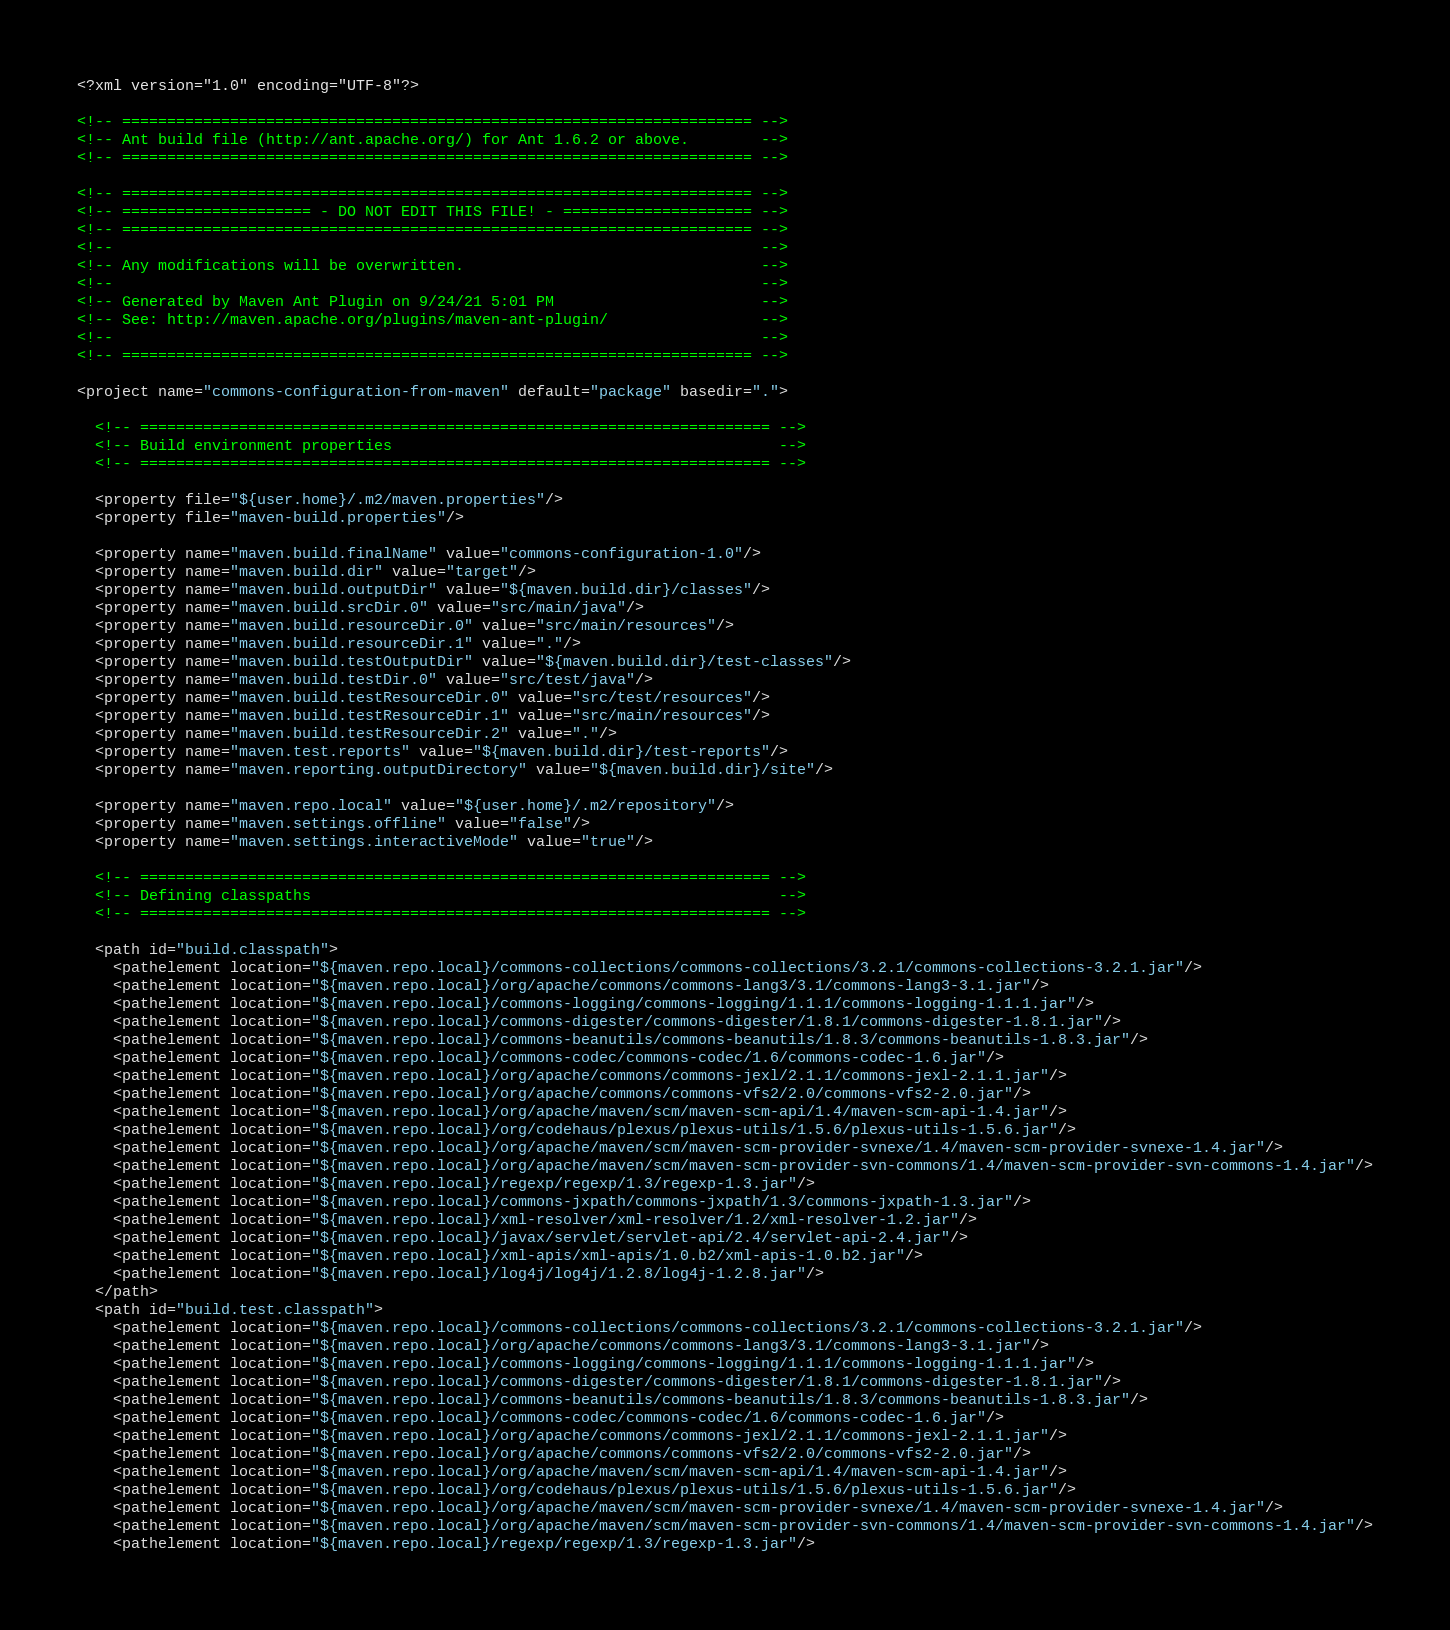Convert code to text. <code><loc_0><loc_0><loc_500><loc_500><_XML_><?xml version="1.0" encoding="UTF-8"?>

<!-- ====================================================================== -->
<!-- Ant build file (http://ant.apache.org/) for Ant 1.6.2 or above.        -->
<!-- ====================================================================== -->

<!-- ====================================================================== -->
<!-- ===================== - DO NOT EDIT THIS FILE! - ===================== -->
<!-- ====================================================================== -->
<!--                                                                        -->
<!-- Any modifications will be overwritten.                                 -->
<!--                                                                        -->
<!-- Generated by Maven Ant Plugin on 9/24/21 5:01 PM                       -->
<!-- See: http://maven.apache.org/plugins/maven-ant-plugin/                 -->
<!--                                                                        -->
<!-- ====================================================================== -->

<project name="commons-configuration-from-maven" default="package" basedir=".">

  <!-- ====================================================================== -->
  <!-- Build environment properties                                           -->
  <!-- ====================================================================== -->

  <property file="${user.home}/.m2/maven.properties"/>
  <property file="maven-build.properties"/>

  <property name="maven.build.finalName" value="commons-configuration-1.0"/>
  <property name="maven.build.dir" value="target"/>
  <property name="maven.build.outputDir" value="${maven.build.dir}/classes"/>
  <property name="maven.build.srcDir.0" value="src/main/java"/>
  <property name="maven.build.resourceDir.0" value="src/main/resources"/>
  <property name="maven.build.resourceDir.1" value="."/>
  <property name="maven.build.testOutputDir" value="${maven.build.dir}/test-classes"/>
  <property name="maven.build.testDir.0" value="src/test/java"/>
  <property name="maven.build.testResourceDir.0" value="src/test/resources"/>
  <property name="maven.build.testResourceDir.1" value="src/main/resources"/>
  <property name="maven.build.testResourceDir.2" value="."/>
  <property name="maven.test.reports" value="${maven.build.dir}/test-reports"/>
  <property name="maven.reporting.outputDirectory" value="${maven.build.dir}/site"/>

  <property name="maven.repo.local" value="${user.home}/.m2/repository"/>
  <property name="maven.settings.offline" value="false"/>
  <property name="maven.settings.interactiveMode" value="true"/>

  <!-- ====================================================================== -->
  <!-- Defining classpaths                                                    -->
  <!-- ====================================================================== -->

  <path id="build.classpath">
    <pathelement location="${maven.repo.local}/commons-collections/commons-collections/3.2.1/commons-collections-3.2.1.jar"/>
    <pathelement location="${maven.repo.local}/org/apache/commons/commons-lang3/3.1/commons-lang3-3.1.jar"/>
    <pathelement location="${maven.repo.local}/commons-logging/commons-logging/1.1.1/commons-logging-1.1.1.jar"/>
    <pathelement location="${maven.repo.local}/commons-digester/commons-digester/1.8.1/commons-digester-1.8.1.jar"/>
    <pathelement location="${maven.repo.local}/commons-beanutils/commons-beanutils/1.8.3/commons-beanutils-1.8.3.jar"/>
    <pathelement location="${maven.repo.local}/commons-codec/commons-codec/1.6/commons-codec-1.6.jar"/>
    <pathelement location="${maven.repo.local}/org/apache/commons/commons-jexl/2.1.1/commons-jexl-2.1.1.jar"/>
    <pathelement location="${maven.repo.local}/org/apache/commons/commons-vfs2/2.0/commons-vfs2-2.0.jar"/>
    <pathelement location="${maven.repo.local}/org/apache/maven/scm/maven-scm-api/1.4/maven-scm-api-1.4.jar"/>
    <pathelement location="${maven.repo.local}/org/codehaus/plexus/plexus-utils/1.5.6/plexus-utils-1.5.6.jar"/>
    <pathelement location="${maven.repo.local}/org/apache/maven/scm/maven-scm-provider-svnexe/1.4/maven-scm-provider-svnexe-1.4.jar"/>
    <pathelement location="${maven.repo.local}/org/apache/maven/scm/maven-scm-provider-svn-commons/1.4/maven-scm-provider-svn-commons-1.4.jar"/>
    <pathelement location="${maven.repo.local}/regexp/regexp/1.3/regexp-1.3.jar"/>
    <pathelement location="${maven.repo.local}/commons-jxpath/commons-jxpath/1.3/commons-jxpath-1.3.jar"/>
    <pathelement location="${maven.repo.local}/xml-resolver/xml-resolver/1.2/xml-resolver-1.2.jar"/>
    <pathelement location="${maven.repo.local}/javax/servlet/servlet-api/2.4/servlet-api-2.4.jar"/>
    <pathelement location="${maven.repo.local}/xml-apis/xml-apis/1.0.b2/xml-apis-1.0.b2.jar"/>
    <pathelement location="${maven.repo.local}/log4j/log4j/1.2.8/log4j-1.2.8.jar"/>
  </path>
  <path id="build.test.classpath">
    <pathelement location="${maven.repo.local}/commons-collections/commons-collections/3.2.1/commons-collections-3.2.1.jar"/>
    <pathelement location="${maven.repo.local}/org/apache/commons/commons-lang3/3.1/commons-lang3-3.1.jar"/>
    <pathelement location="${maven.repo.local}/commons-logging/commons-logging/1.1.1/commons-logging-1.1.1.jar"/>
    <pathelement location="${maven.repo.local}/commons-digester/commons-digester/1.8.1/commons-digester-1.8.1.jar"/>
    <pathelement location="${maven.repo.local}/commons-beanutils/commons-beanutils/1.8.3/commons-beanutils-1.8.3.jar"/>
    <pathelement location="${maven.repo.local}/commons-codec/commons-codec/1.6/commons-codec-1.6.jar"/>
    <pathelement location="${maven.repo.local}/org/apache/commons/commons-jexl/2.1.1/commons-jexl-2.1.1.jar"/>
    <pathelement location="${maven.repo.local}/org/apache/commons/commons-vfs2/2.0/commons-vfs2-2.0.jar"/>
    <pathelement location="${maven.repo.local}/org/apache/maven/scm/maven-scm-api/1.4/maven-scm-api-1.4.jar"/>
    <pathelement location="${maven.repo.local}/org/codehaus/plexus/plexus-utils/1.5.6/plexus-utils-1.5.6.jar"/>
    <pathelement location="${maven.repo.local}/org/apache/maven/scm/maven-scm-provider-svnexe/1.4/maven-scm-provider-svnexe-1.4.jar"/>
    <pathelement location="${maven.repo.local}/org/apache/maven/scm/maven-scm-provider-svn-commons/1.4/maven-scm-provider-svn-commons-1.4.jar"/>
    <pathelement location="${maven.repo.local}/regexp/regexp/1.3/regexp-1.3.jar"/></code> 